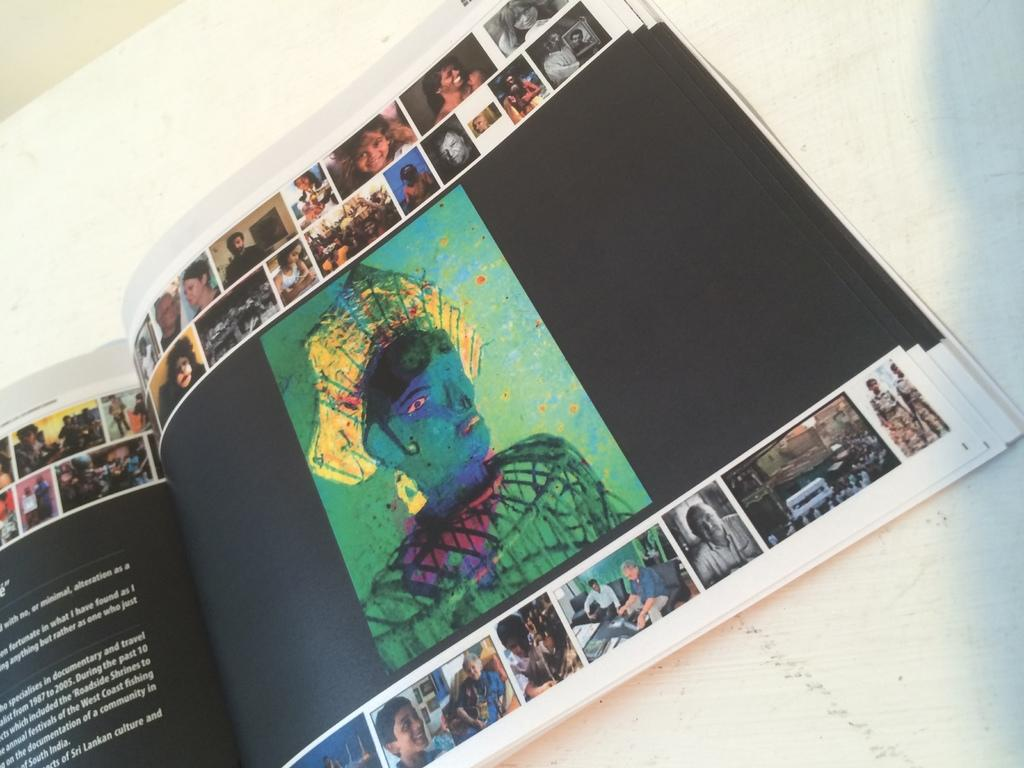What is the main object in the image? There is a book in the image. What can be seen on the pages of the book? The book has photos printed on its pages. What other artistic element is present in the image? There is a painting in the image. Can you describe the text on the book? There is some text on the left side of the book. How many pairs of shoes are visible in the image? There are no shoes visible in the image. Is there a bed in the image? There is no bed present in the image. 